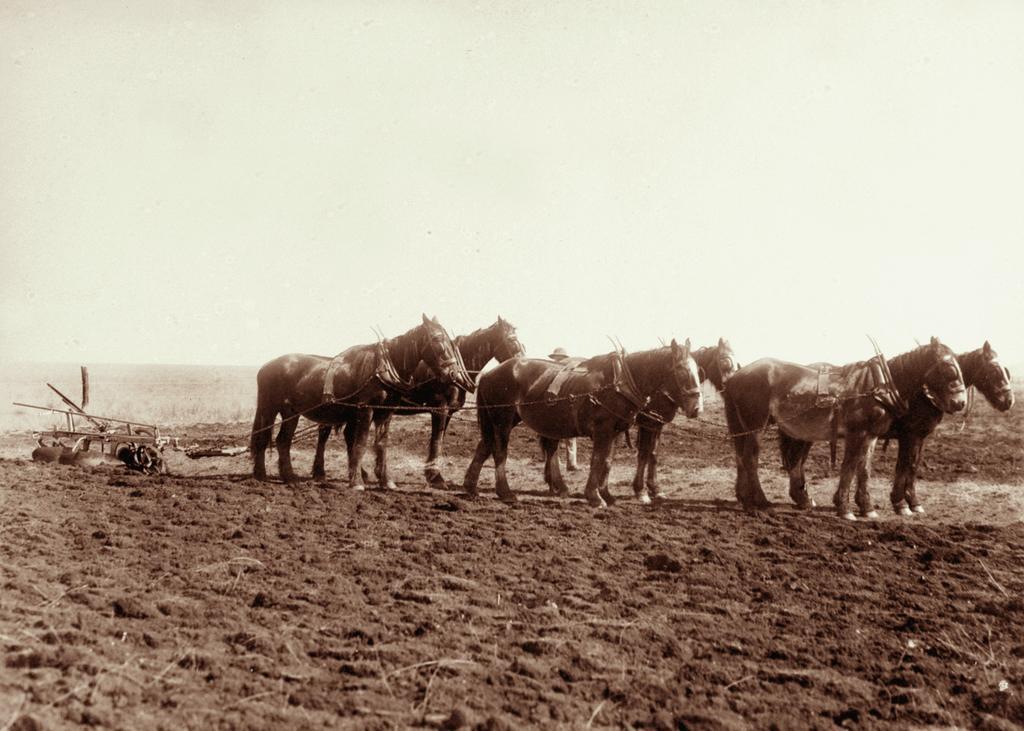In one or two sentences, can you explain what this image depicts? In this picture we can see few horses in the field, in the background we can see few plants. 